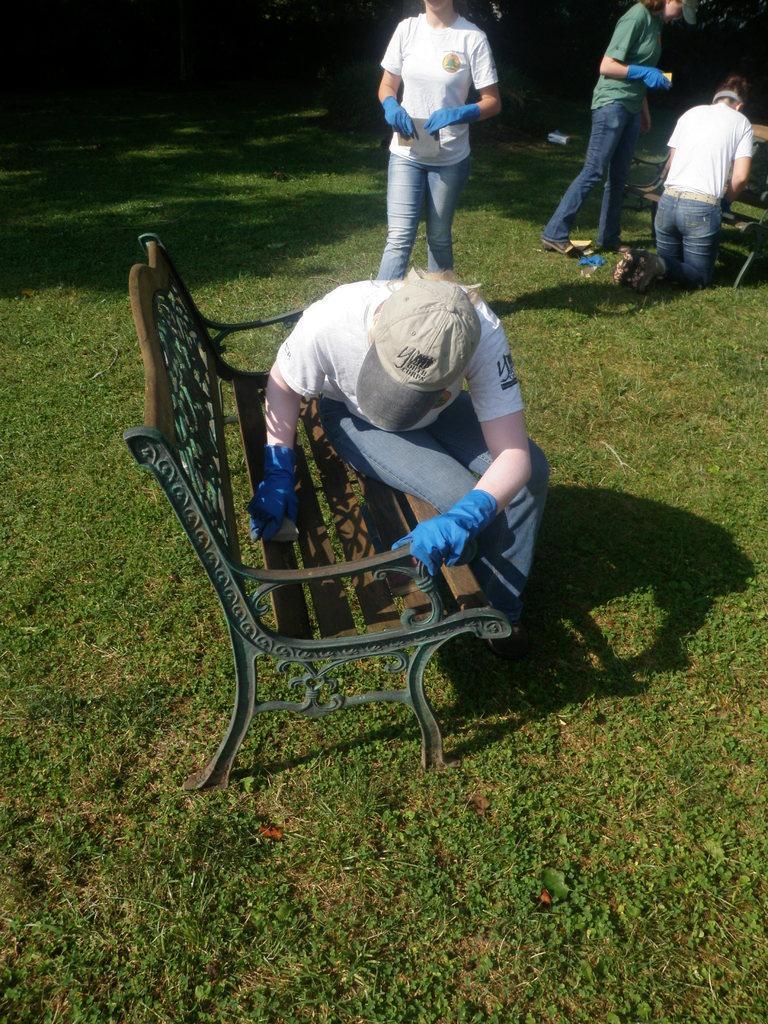In one or two sentences, can you explain what this image depicts? In this picture I can see there is a man sitting on a bench and in the backdrop there are some people standing and on the floor there is grass. 